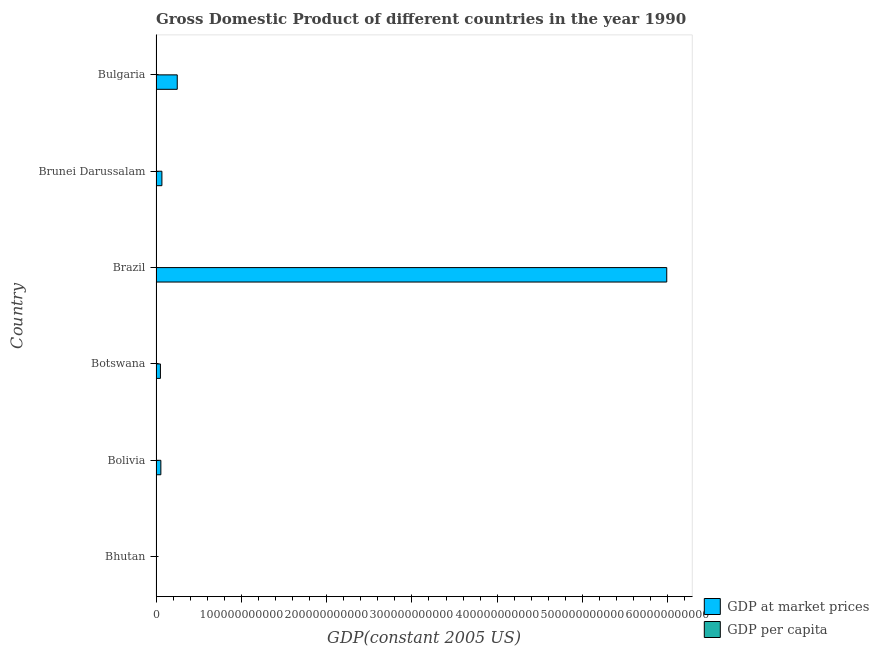How many different coloured bars are there?
Offer a very short reply. 2. How many bars are there on the 4th tick from the bottom?
Ensure brevity in your answer.  2. What is the label of the 2nd group of bars from the top?
Offer a very short reply. Brunei Darussalam. What is the gdp per capita in Bolivia?
Provide a succinct answer. 826.29. Across all countries, what is the maximum gdp per capita?
Provide a short and direct response. 2.68e+04. Across all countries, what is the minimum gdp at market prices?
Your answer should be compact. 3.45e+08. In which country was the gdp per capita maximum?
Give a very brief answer. Brunei Darussalam. In which country was the gdp at market prices minimum?
Offer a very short reply. Bhutan. What is the total gdp at market prices in the graph?
Offer a very short reply. 6.42e+11. What is the difference between the gdp at market prices in Brunei Darussalam and that in Bulgaria?
Provide a succinct answer. -1.80e+1. What is the difference between the gdp at market prices in Botswana and the gdp per capita in Bolivia?
Your answer should be compact. 5.16e+09. What is the average gdp at market prices per country?
Make the answer very short. 1.07e+11. What is the difference between the gdp at market prices and gdp per capita in Botswana?
Offer a terse response. 5.16e+09. In how many countries, is the gdp per capita greater than 340000000000 US$?
Provide a succinct answer. 0. What is the ratio of the gdp per capita in Brunei Darussalam to that in Bulgaria?
Give a very brief answer. 9.4. What is the difference between the highest and the second highest gdp per capita?
Your response must be concise. 2.28e+04. What is the difference between the highest and the lowest gdp per capita?
Your answer should be very brief. 2.62e+04. In how many countries, is the gdp at market prices greater than the average gdp at market prices taken over all countries?
Offer a terse response. 1. Is the sum of the gdp at market prices in Bhutan and Botswana greater than the maximum gdp per capita across all countries?
Provide a succinct answer. Yes. What does the 2nd bar from the top in Bulgaria represents?
Offer a very short reply. GDP at market prices. What does the 2nd bar from the bottom in Bhutan represents?
Provide a succinct answer. GDP per capita. How many bars are there?
Provide a short and direct response. 12. Are all the bars in the graph horizontal?
Provide a succinct answer. Yes. What is the difference between two consecutive major ticks on the X-axis?
Your answer should be compact. 1.00e+11. Does the graph contain any zero values?
Ensure brevity in your answer.  No. Where does the legend appear in the graph?
Your answer should be very brief. Bottom right. How many legend labels are there?
Provide a succinct answer. 2. What is the title of the graph?
Keep it short and to the point. Gross Domestic Product of different countries in the year 1990. Does "Number of arrivals" appear as one of the legend labels in the graph?
Make the answer very short. No. What is the label or title of the X-axis?
Provide a succinct answer. GDP(constant 2005 US). What is the GDP(constant 2005 US) of GDP at market prices in Bhutan?
Ensure brevity in your answer.  3.45e+08. What is the GDP(constant 2005 US) of GDP per capita in Bhutan?
Offer a very short reply. 643.37. What is the GDP(constant 2005 US) in GDP at market prices in Bolivia?
Your answer should be compact. 5.67e+09. What is the GDP(constant 2005 US) of GDP per capita in Bolivia?
Offer a very short reply. 826.29. What is the GDP(constant 2005 US) in GDP at market prices in Botswana?
Keep it short and to the point. 5.16e+09. What is the GDP(constant 2005 US) in GDP per capita in Botswana?
Keep it short and to the point. 3741.72. What is the GDP(constant 2005 US) of GDP at market prices in Brazil?
Your answer should be very brief. 5.99e+11. What is the GDP(constant 2005 US) in GDP per capita in Brazil?
Give a very brief answer. 3981.71. What is the GDP(constant 2005 US) in GDP at market prices in Brunei Darussalam?
Your answer should be very brief. 6.89e+09. What is the GDP(constant 2005 US) of GDP per capita in Brunei Darussalam?
Keep it short and to the point. 2.68e+04. What is the GDP(constant 2005 US) in GDP at market prices in Bulgaria?
Your response must be concise. 2.49e+1. What is the GDP(constant 2005 US) in GDP per capita in Bulgaria?
Provide a short and direct response. 2854.63. Across all countries, what is the maximum GDP(constant 2005 US) of GDP at market prices?
Keep it short and to the point. 5.99e+11. Across all countries, what is the maximum GDP(constant 2005 US) in GDP per capita?
Your answer should be very brief. 2.68e+04. Across all countries, what is the minimum GDP(constant 2005 US) in GDP at market prices?
Provide a succinct answer. 3.45e+08. Across all countries, what is the minimum GDP(constant 2005 US) in GDP per capita?
Make the answer very short. 643.37. What is the total GDP(constant 2005 US) in GDP at market prices in the graph?
Provide a short and direct response. 6.42e+11. What is the total GDP(constant 2005 US) of GDP per capita in the graph?
Make the answer very short. 3.89e+04. What is the difference between the GDP(constant 2005 US) of GDP at market prices in Bhutan and that in Bolivia?
Your answer should be very brief. -5.32e+09. What is the difference between the GDP(constant 2005 US) of GDP per capita in Bhutan and that in Bolivia?
Provide a succinct answer. -182.92. What is the difference between the GDP(constant 2005 US) in GDP at market prices in Bhutan and that in Botswana?
Provide a succinct answer. -4.82e+09. What is the difference between the GDP(constant 2005 US) in GDP per capita in Bhutan and that in Botswana?
Give a very brief answer. -3098.35. What is the difference between the GDP(constant 2005 US) in GDP at market prices in Bhutan and that in Brazil?
Make the answer very short. -5.98e+11. What is the difference between the GDP(constant 2005 US) of GDP per capita in Bhutan and that in Brazil?
Provide a succinct answer. -3338.33. What is the difference between the GDP(constant 2005 US) of GDP at market prices in Bhutan and that in Brunei Darussalam?
Your answer should be very brief. -6.55e+09. What is the difference between the GDP(constant 2005 US) in GDP per capita in Bhutan and that in Brunei Darussalam?
Offer a terse response. -2.62e+04. What is the difference between the GDP(constant 2005 US) of GDP at market prices in Bhutan and that in Bulgaria?
Provide a succinct answer. -2.45e+1. What is the difference between the GDP(constant 2005 US) in GDP per capita in Bhutan and that in Bulgaria?
Keep it short and to the point. -2211.25. What is the difference between the GDP(constant 2005 US) of GDP at market prices in Bolivia and that in Botswana?
Your answer should be very brief. 5.02e+08. What is the difference between the GDP(constant 2005 US) of GDP per capita in Bolivia and that in Botswana?
Provide a short and direct response. -2915.43. What is the difference between the GDP(constant 2005 US) of GDP at market prices in Bolivia and that in Brazil?
Your response must be concise. -5.93e+11. What is the difference between the GDP(constant 2005 US) in GDP per capita in Bolivia and that in Brazil?
Provide a short and direct response. -3155.42. What is the difference between the GDP(constant 2005 US) in GDP at market prices in Bolivia and that in Brunei Darussalam?
Provide a succinct answer. -1.23e+09. What is the difference between the GDP(constant 2005 US) of GDP per capita in Bolivia and that in Brunei Darussalam?
Ensure brevity in your answer.  -2.60e+04. What is the difference between the GDP(constant 2005 US) in GDP at market prices in Bolivia and that in Bulgaria?
Your answer should be compact. -1.92e+1. What is the difference between the GDP(constant 2005 US) in GDP per capita in Bolivia and that in Bulgaria?
Ensure brevity in your answer.  -2028.34. What is the difference between the GDP(constant 2005 US) of GDP at market prices in Botswana and that in Brazil?
Give a very brief answer. -5.94e+11. What is the difference between the GDP(constant 2005 US) in GDP per capita in Botswana and that in Brazil?
Provide a succinct answer. -239.98. What is the difference between the GDP(constant 2005 US) in GDP at market prices in Botswana and that in Brunei Darussalam?
Provide a succinct answer. -1.73e+09. What is the difference between the GDP(constant 2005 US) of GDP per capita in Botswana and that in Brunei Darussalam?
Give a very brief answer. -2.31e+04. What is the difference between the GDP(constant 2005 US) in GDP at market prices in Botswana and that in Bulgaria?
Give a very brief answer. -1.97e+1. What is the difference between the GDP(constant 2005 US) of GDP per capita in Botswana and that in Bulgaria?
Give a very brief answer. 887.09. What is the difference between the GDP(constant 2005 US) of GDP at market prices in Brazil and that in Brunei Darussalam?
Your answer should be compact. 5.92e+11. What is the difference between the GDP(constant 2005 US) of GDP per capita in Brazil and that in Brunei Darussalam?
Provide a short and direct response. -2.28e+04. What is the difference between the GDP(constant 2005 US) of GDP at market prices in Brazil and that in Bulgaria?
Your answer should be compact. 5.74e+11. What is the difference between the GDP(constant 2005 US) in GDP per capita in Brazil and that in Bulgaria?
Provide a succinct answer. 1127.08. What is the difference between the GDP(constant 2005 US) of GDP at market prices in Brunei Darussalam and that in Bulgaria?
Keep it short and to the point. -1.80e+1. What is the difference between the GDP(constant 2005 US) of GDP per capita in Brunei Darussalam and that in Bulgaria?
Your answer should be very brief. 2.40e+04. What is the difference between the GDP(constant 2005 US) of GDP at market prices in Bhutan and the GDP(constant 2005 US) of GDP per capita in Bolivia?
Give a very brief answer. 3.45e+08. What is the difference between the GDP(constant 2005 US) of GDP at market prices in Bhutan and the GDP(constant 2005 US) of GDP per capita in Botswana?
Offer a very short reply. 3.45e+08. What is the difference between the GDP(constant 2005 US) of GDP at market prices in Bhutan and the GDP(constant 2005 US) of GDP per capita in Brazil?
Keep it short and to the point. 3.45e+08. What is the difference between the GDP(constant 2005 US) of GDP at market prices in Bhutan and the GDP(constant 2005 US) of GDP per capita in Brunei Darussalam?
Provide a succinct answer. 3.45e+08. What is the difference between the GDP(constant 2005 US) of GDP at market prices in Bhutan and the GDP(constant 2005 US) of GDP per capita in Bulgaria?
Your response must be concise. 3.45e+08. What is the difference between the GDP(constant 2005 US) in GDP at market prices in Bolivia and the GDP(constant 2005 US) in GDP per capita in Botswana?
Offer a very short reply. 5.67e+09. What is the difference between the GDP(constant 2005 US) in GDP at market prices in Bolivia and the GDP(constant 2005 US) in GDP per capita in Brazil?
Provide a succinct answer. 5.67e+09. What is the difference between the GDP(constant 2005 US) in GDP at market prices in Bolivia and the GDP(constant 2005 US) in GDP per capita in Brunei Darussalam?
Provide a succinct answer. 5.67e+09. What is the difference between the GDP(constant 2005 US) of GDP at market prices in Bolivia and the GDP(constant 2005 US) of GDP per capita in Bulgaria?
Make the answer very short. 5.67e+09. What is the difference between the GDP(constant 2005 US) of GDP at market prices in Botswana and the GDP(constant 2005 US) of GDP per capita in Brazil?
Your answer should be compact. 5.16e+09. What is the difference between the GDP(constant 2005 US) in GDP at market prices in Botswana and the GDP(constant 2005 US) in GDP per capita in Brunei Darussalam?
Provide a succinct answer. 5.16e+09. What is the difference between the GDP(constant 2005 US) of GDP at market prices in Botswana and the GDP(constant 2005 US) of GDP per capita in Bulgaria?
Ensure brevity in your answer.  5.16e+09. What is the difference between the GDP(constant 2005 US) in GDP at market prices in Brazil and the GDP(constant 2005 US) in GDP per capita in Brunei Darussalam?
Ensure brevity in your answer.  5.99e+11. What is the difference between the GDP(constant 2005 US) of GDP at market prices in Brazil and the GDP(constant 2005 US) of GDP per capita in Bulgaria?
Make the answer very short. 5.99e+11. What is the difference between the GDP(constant 2005 US) in GDP at market prices in Brunei Darussalam and the GDP(constant 2005 US) in GDP per capita in Bulgaria?
Make the answer very short. 6.89e+09. What is the average GDP(constant 2005 US) in GDP at market prices per country?
Keep it short and to the point. 1.07e+11. What is the average GDP(constant 2005 US) of GDP per capita per country?
Make the answer very short. 6479.62. What is the difference between the GDP(constant 2005 US) in GDP at market prices and GDP(constant 2005 US) in GDP per capita in Bhutan?
Offer a very short reply. 3.45e+08. What is the difference between the GDP(constant 2005 US) in GDP at market prices and GDP(constant 2005 US) in GDP per capita in Bolivia?
Your answer should be compact. 5.67e+09. What is the difference between the GDP(constant 2005 US) in GDP at market prices and GDP(constant 2005 US) in GDP per capita in Botswana?
Make the answer very short. 5.16e+09. What is the difference between the GDP(constant 2005 US) of GDP at market prices and GDP(constant 2005 US) of GDP per capita in Brazil?
Make the answer very short. 5.99e+11. What is the difference between the GDP(constant 2005 US) of GDP at market prices and GDP(constant 2005 US) of GDP per capita in Brunei Darussalam?
Offer a terse response. 6.89e+09. What is the difference between the GDP(constant 2005 US) in GDP at market prices and GDP(constant 2005 US) in GDP per capita in Bulgaria?
Make the answer very short. 2.49e+1. What is the ratio of the GDP(constant 2005 US) in GDP at market prices in Bhutan to that in Bolivia?
Ensure brevity in your answer.  0.06. What is the ratio of the GDP(constant 2005 US) of GDP per capita in Bhutan to that in Bolivia?
Give a very brief answer. 0.78. What is the ratio of the GDP(constant 2005 US) of GDP at market prices in Bhutan to that in Botswana?
Provide a short and direct response. 0.07. What is the ratio of the GDP(constant 2005 US) in GDP per capita in Bhutan to that in Botswana?
Offer a terse response. 0.17. What is the ratio of the GDP(constant 2005 US) in GDP at market prices in Bhutan to that in Brazil?
Keep it short and to the point. 0. What is the ratio of the GDP(constant 2005 US) of GDP per capita in Bhutan to that in Brazil?
Provide a succinct answer. 0.16. What is the ratio of the GDP(constant 2005 US) in GDP per capita in Bhutan to that in Brunei Darussalam?
Keep it short and to the point. 0.02. What is the ratio of the GDP(constant 2005 US) of GDP at market prices in Bhutan to that in Bulgaria?
Make the answer very short. 0.01. What is the ratio of the GDP(constant 2005 US) in GDP per capita in Bhutan to that in Bulgaria?
Offer a very short reply. 0.23. What is the ratio of the GDP(constant 2005 US) in GDP at market prices in Bolivia to that in Botswana?
Ensure brevity in your answer.  1.1. What is the ratio of the GDP(constant 2005 US) of GDP per capita in Bolivia to that in Botswana?
Your answer should be compact. 0.22. What is the ratio of the GDP(constant 2005 US) in GDP at market prices in Bolivia to that in Brazil?
Make the answer very short. 0.01. What is the ratio of the GDP(constant 2005 US) in GDP per capita in Bolivia to that in Brazil?
Make the answer very short. 0.21. What is the ratio of the GDP(constant 2005 US) in GDP at market prices in Bolivia to that in Brunei Darussalam?
Your response must be concise. 0.82. What is the ratio of the GDP(constant 2005 US) of GDP per capita in Bolivia to that in Brunei Darussalam?
Make the answer very short. 0.03. What is the ratio of the GDP(constant 2005 US) in GDP at market prices in Bolivia to that in Bulgaria?
Provide a short and direct response. 0.23. What is the ratio of the GDP(constant 2005 US) of GDP per capita in Bolivia to that in Bulgaria?
Your answer should be very brief. 0.29. What is the ratio of the GDP(constant 2005 US) in GDP at market prices in Botswana to that in Brazil?
Offer a terse response. 0.01. What is the ratio of the GDP(constant 2005 US) of GDP per capita in Botswana to that in Brazil?
Offer a very short reply. 0.94. What is the ratio of the GDP(constant 2005 US) in GDP at market prices in Botswana to that in Brunei Darussalam?
Give a very brief answer. 0.75. What is the ratio of the GDP(constant 2005 US) in GDP per capita in Botswana to that in Brunei Darussalam?
Provide a succinct answer. 0.14. What is the ratio of the GDP(constant 2005 US) of GDP at market prices in Botswana to that in Bulgaria?
Ensure brevity in your answer.  0.21. What is the ratio of the GDP(constant 2005 US) in GDP per capita in Botswana to that in Bulgaria?
Keep it short and to the point. 1.31. What is the ratio of the GDP(constant 2005 US) of GDP at market prices in Brazil to that in Brunei Darussalam?
Provide a short and direct response. 86.87. What is the ratio of the GDP(constant 2005 US) of GDP per capita in Brazil to that in Brunei Darussalam?
Provide a short and direct response. 0.15. What is the ratio of the GDP(constant 2005 US) of GDP at market prices in Brazil to that in Bulgaria?
Keep it short and to the point. 24.06. What is the ratio of the GDP(constant 2005 US) of GDP per capita in Brazil to that in Bulgaria?
Keep it short and to the point. 1.39. What is the ratio of the GDP(constant 2005 US) of GDP at market prices in Brunei Darussalam to that in Bulgaria?
Provide a short and direct response. 0.28. What is the ratio of the GDP(constant 2005 US) of GDP per capita in Brunei Darussalam to that in Bulgaria?
Your response must be concise. 9.4. What is the difference between the highest and the second highest GDP(constant 2005 US) of GDP at market prices?
Give a very brief answer. 5.74e+11. What is the difference between the highest and the second highest GDP(constant 2005 US) of GDP per capita?
Provide a succinct answer. 2.28e+04. What is the difference between the highest and the lowest GDP(constant 2005 US) in GDP at market prices?
Provide a short and direct response. 5.98e+11. What is the difference between the highest and the lowest GDP(constant 2005 US) of GDP per capita?
Keep it short and to the point. 2.62e+04. 